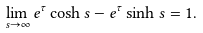Convert formula to latex. <formula><loc_0><loc_0><loc_500><loc_500>\lim _ { s \rightarrow \infty } e ^ { \tau } \cosh s - e ^ { \tau } \sinh s = 1 .</formula> 